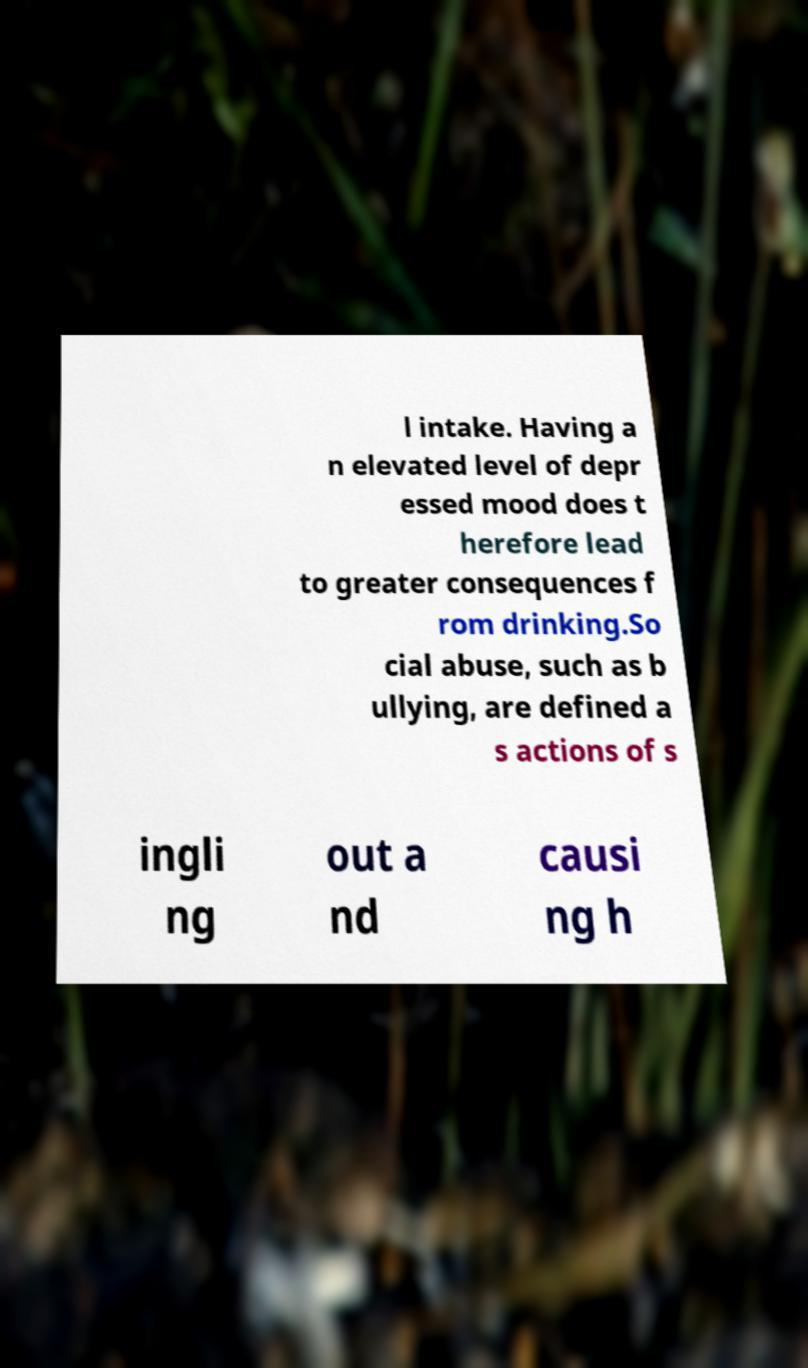What messages or text are displayed in this image? I need them in a readable, typed format. l intake. Having a n elevated level of depr essed mood does t herefore lead to greater consequences f rom drinking.So cial abuse, such as b ullying, are defined a s actions of s ingli ng out a nd causi ng h 